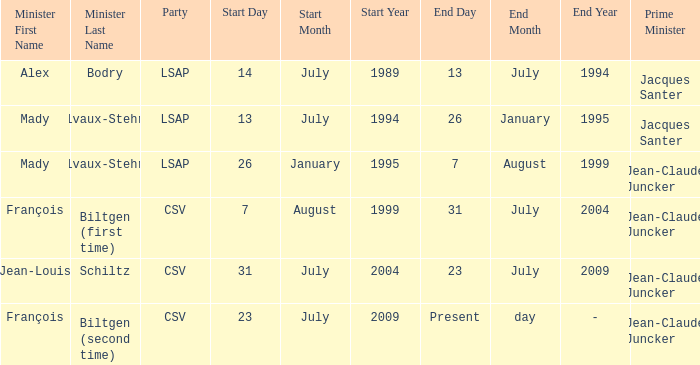What was the end date when Alex Bodry was the minister? 13 July 1994. 